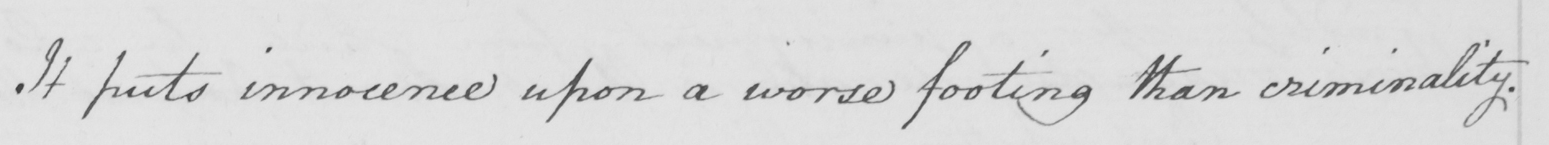Can you read and transcribe this handwriting? It puts innocence upon a worse footing than criminality . 